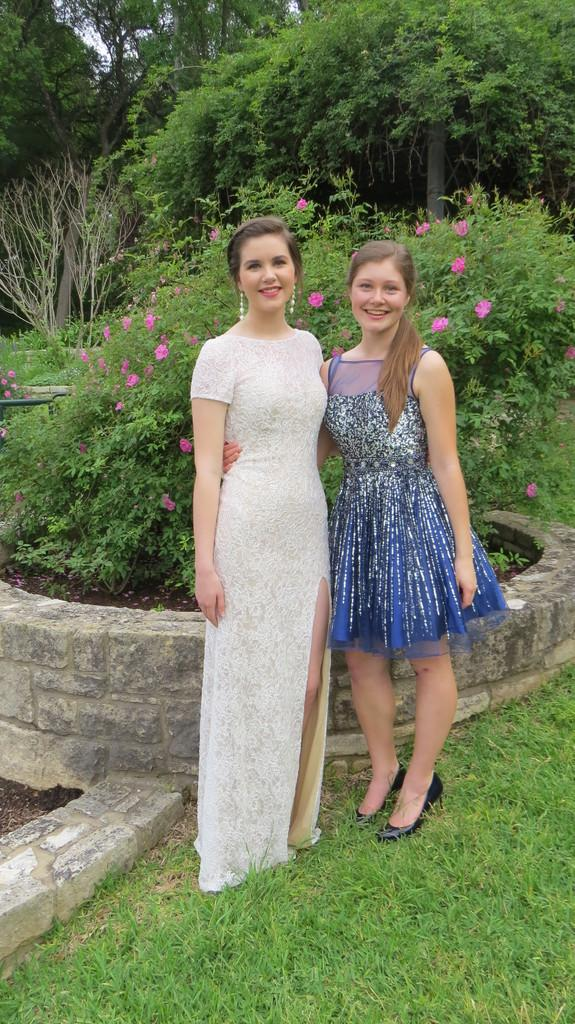How many women are present in the image? There are two women standing on the grass. What is located behind the women? There is an architecture and a plant behind the women. What type of vegetation is visible behind the women? There are trees behind the women. What can be seen in the sky behind the trees? The sky is visible behind the trees. What type of growth can be seen on the women's faces in the image? There is no growth visible on the women's faces in the image. What type of loss is depicted in the image? There is no loss depicted in the image. 